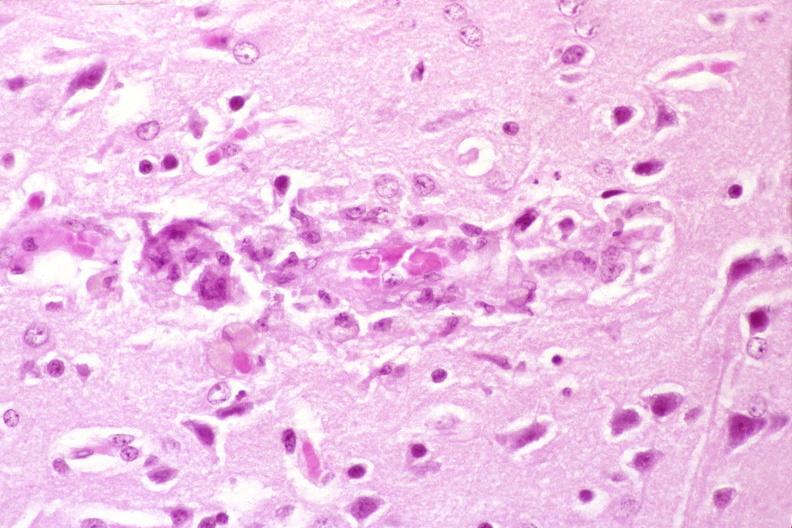what does this image show?
Answer the question using a single word or phrase. Brain 